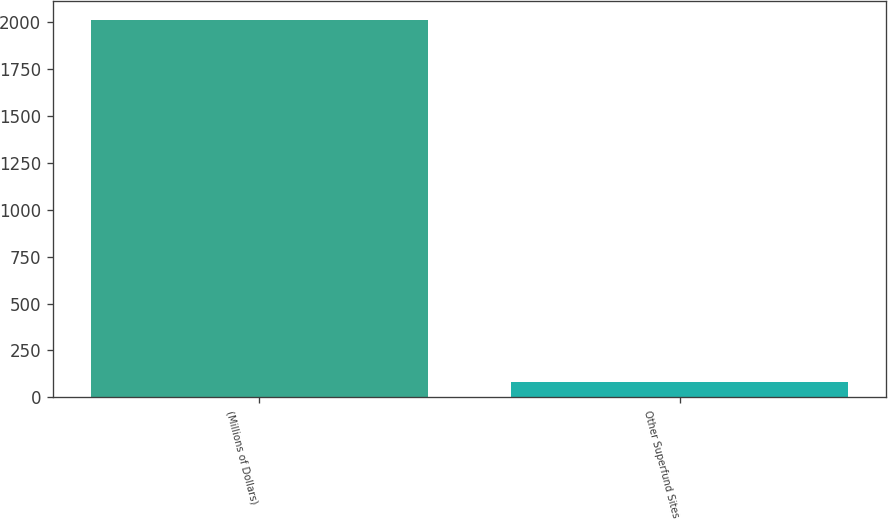<chart> <loc_0><loc_0><loc_500><loc_500><bar_chart><fcel>(Millions of Dollars)<fcel>Other Superfund Sites<nl><fcel>2012<fcel>83<nl></chart> 